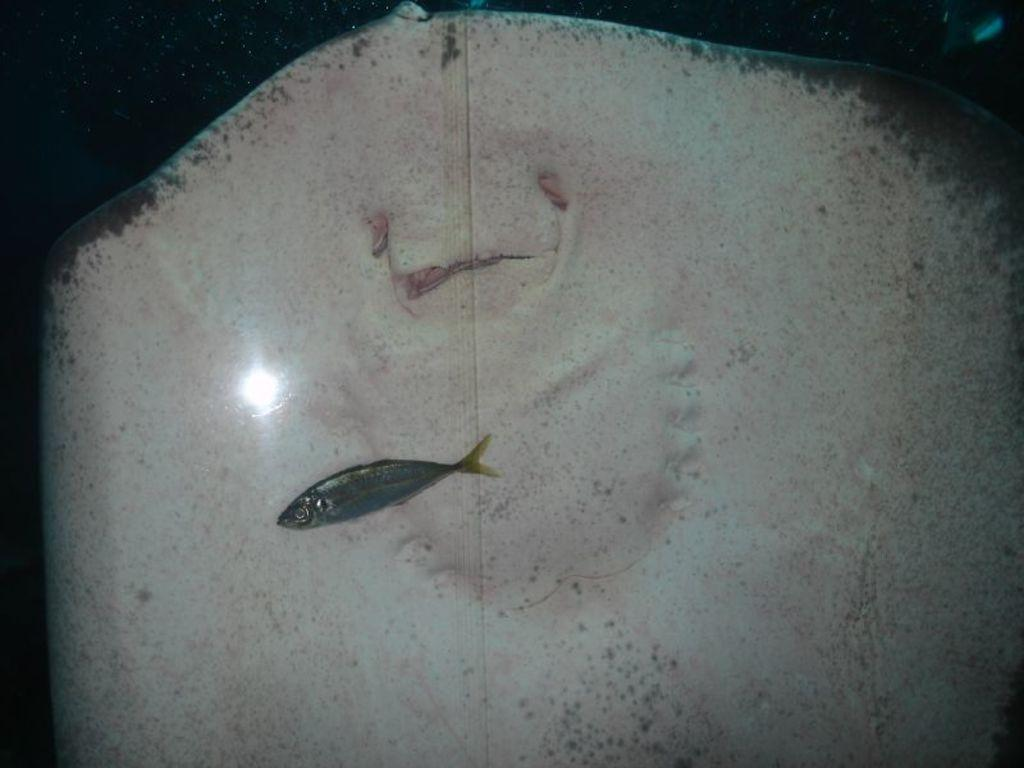How many fishes can be seen in the image? There are two fishes in the image. What is the lighting condition in the water? There is light in the water. Can you determine the time of day based on the image? The image may have been taken during the night. What type of record can be seen in the image? There is no record present in the image; it features two fishes in the water. Can you tell me how many donkeys are visible in the image? There are no donkeys present in the image. 